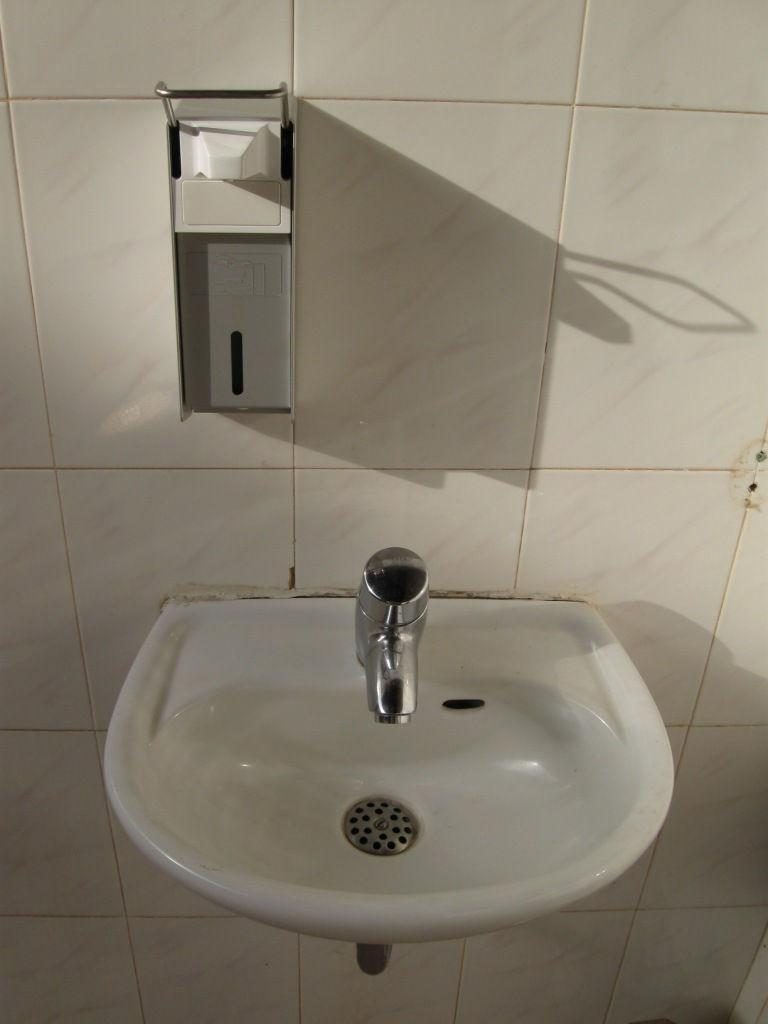What is the main object in the image? There is a wash basin in the image. What is attached to the wash basin? There is a tap in the image. What is the material of the wall behind the wash basin? The wall behind the wash basin is made up of white tiles. What is present near the wash basin for hygiene purposes? There is a tissue stand or a sanitizer box in the image. How many sisters are present in the image? There are no sisters present in the image; it features a wash basin, a tap, white tiles, and a tissue stand or sanitizer box. 